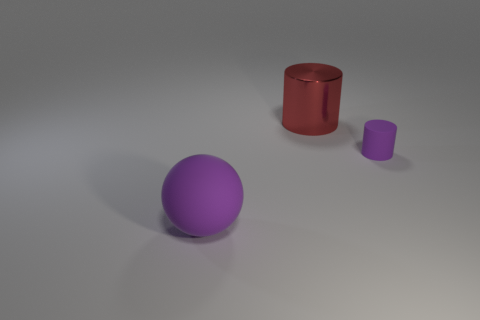Is there anything else that is the same size as the rubber cylinder?
Your answer should be very brief. No. What is the size of the purple rubber thing that is right of the red shiny thing?
Give a very brief answer. Small. Does the ball have the same color as the rubber thing right of the large red metal thing?
Your response must be concise. Yes. Is there a tiny cylinder that has the same color as the metal object?
Provide a short and direct response. No. Do the red object and the cylinder that is in front of the big red cylinder have the same material?
Ensure brevity in your answer.  No. What number of small things are either green rubber cubes or purple spheres?
Your answer should be very brief. 0. There is a big sphere that is the same color as the tiny cylinder; what is it made of?
Your answer should be very brief. Rubber. Are there fewer big gray shiny objects than rubber cylinders?
Make the answer very short. Yes. There is a object behind the purple matte cylinder; is its size the same as the rubber thing on the left side of the red metal cylinder?
Ensure brevity in your answer.  Yes. What number of green objects are matte things or cylinders?
Provide a succinct answer. 0. 